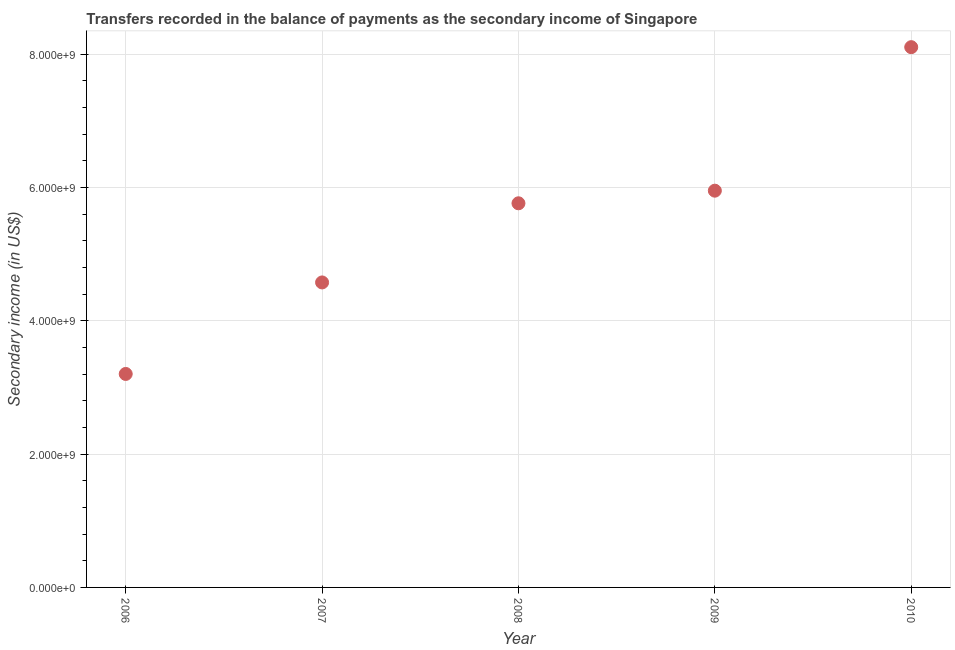What is the amount of secondary income in 2006?
Keep it short and to the point. 3.20e+09. Across all years, what is the maximum amount of secondary income?
Your answer should be compact. 8.11e+09. Across all years, what is the minimum amount of secondary income?
Your answer should be very brief. 3.20e+09. In which year was the amount of secondary income minimum?
Offer a very short reply. 2006. What is the sum of the amount of secondary income?
Keep it short and to the point. 2.76e+1. What is the difference between the amount of secondary income in 2007 and 2009?
Keep it short and to the point. -1.38e+09. What is the average amount of secondary income per year?
Make the answer very short. 5.52e+09. What is the median amount of secondary income?
Offer a very short reply. 5.76e+09. What is the ratio of the amount of secondary income in 2006 to that in 2009?
Your answer should be compact. 0.54. Is the amount of secondary income in 2006 less than that in 2009?
Offer a very short reply. Yes. Is the difference between the amount of secondary income in 2006 and 2010 greater than the difference between any two years?
Keep it short and to the point. Yes. What is the difference between the highest and the second highest amount of secondary income?
Your response must be concise. 2.15e+09. Is the sum of the amount of secondary income in 2008 and 2010 greater than the maximum amount of secondary income across all years?
Your answer should be compact. Yes. What is the difference between the highest and the lowest amount of secondary income?
Keep it short and to the point. 4.90e+09. How many dotlines are there?
Make the answer very short. 1. How many years are there in the graph?
Offer a terse response. 5. What is the difference between two consecutive major ticks on the Y-axis?
Offer a terse response. 2.00e+09. Does the graph contain grids?
Offer a very short reply. Yes. What is the title of the graph?
Give a very brief answer. Transfers recorded in the balance of payments as the secondary income of Singapore. What is the label or title of the Y-axis?
Offer a very short reply. Secondary income (in US$). What is the Secondary income (in US$) in 2006?
Your answer should be very brief. 3.20e+09. What is the Secondary income (in US$) in 2007?
Offer a terse response. 4.58e+09. What is the Secondary income (in US$) in 2008?
Ensure brevity in your answer.  5.76e+09. What is the Secondary income (in US$) in 2009?
Your answer should be compact. 5.95e+09. What is the Secondary income (in US$) in 2010?
Ensure brevity in your answer.  8.11e+09. What is the difference between the Secondary income (in US$) in 2006 and 2007?
Ensure brevity in your answer.  -1.37e+09. What is the difference between the Secondary income (in US$) in 2006 and 2008?
Keep it short and to the point. -2.56e+09. What is the difference between the Secondary income (in US$) in 2006 and 2009?
Provide a short and direct response. -2.75e+09. What is the difference between the Secondary income (in US$) in 2006 and 2010?
Make the answer very short. -4.90e+09. What is the difference between the Secondary income (in US$) in 2007 and 2008?
Offer a very short reply. -1.19e+09. What is the difference between the Secondary income (in US$) in 2007 and 2009?
Give a very brief answer. -1.38e+09. What is the difference between the Secondary income (in US$) in 2007 and 2010?
Provide a succinct answer. -3.53e+09. What is the difference between the Secondary income (in US$) in 2008 and 2009?
Your response must be concise. -1.89e+08. What is the difference between the Secondary income (in US$) in 2008 and 2010?
Ensure brevity in your answer.  -2.34e+09. What is the difference between the Secondary income (in US$) in 2009 and 2010?
Your response must be concise. -2.15e+09. What is the ratio of the Secondary income (in US$) in 2006 to that in 2007?
Ensure brevity in your answer.  0.7. What is the ratio of the Secondary income (in US$) in 2006 to that in 2008?
Provide a succinct answer. 0.56. What is the ratio of the Secondary income (in US$) in 2006 to that in 2009?
Your response must be concise. 0.54. What is the ratio of the Secondary income (in US$) in 2006 to that in 2010?
Your answer should be compact. 0.4. What is the ratio of the Secondary income (in US$) in 2007 to that in 2008?
Offer a very short reply. 0.79. What is the ratio of the Secondary income (in US$) in 2007 to that in 2009?
Keep it short and to the point. 0.77. What is the ratio of the Secondary income (in US$) in 2007 to that in 2010?
Make the answer very short. 0.56. What is the ratio of the Secondary income (in US$) in 2008 to that in 2009?
Offer a terse response. 0.97. What is the ratio of the Secondary income (in US$) in 2008 to that in 2010?
Offer a very short reply. 0.71. What is the ratio of the Secondary income (in US$) in 2009 to that in 2010?
Offer a terse response. 0.73. 